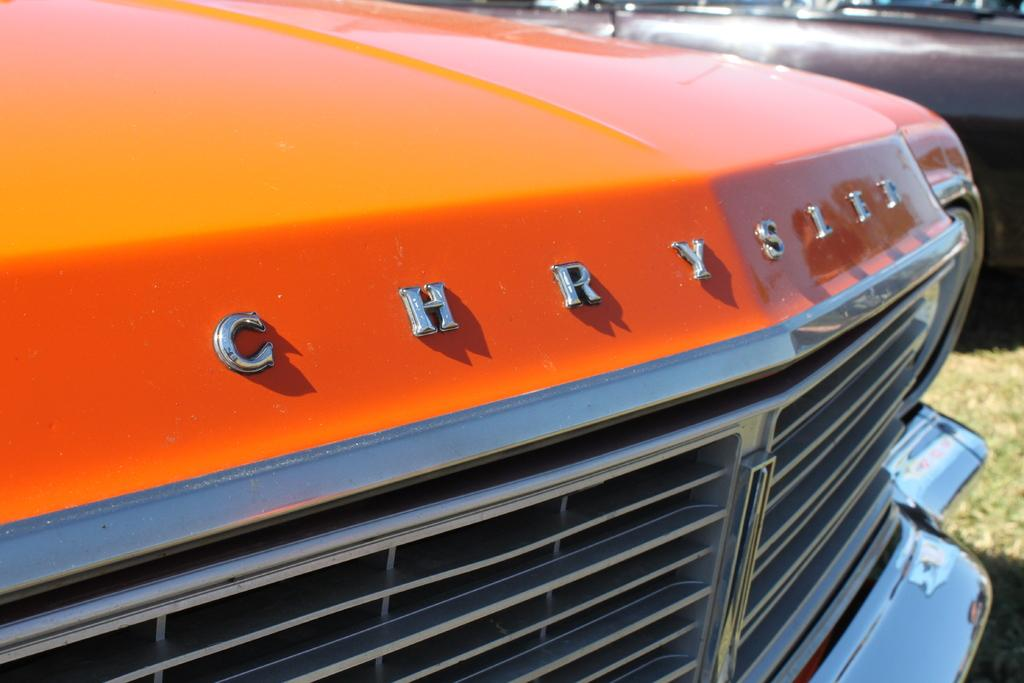What type of vehicles are present in the image? There are cars in the image. How are the cars positioned in relation to other elements in the image? The cars are in front of other elements in the image. What type of surface is visible in the image? There is grass visible on the surface in the image. What type of story is being told in the crib in the image? There is no crib present in the image, so no story is being told in a crib. 